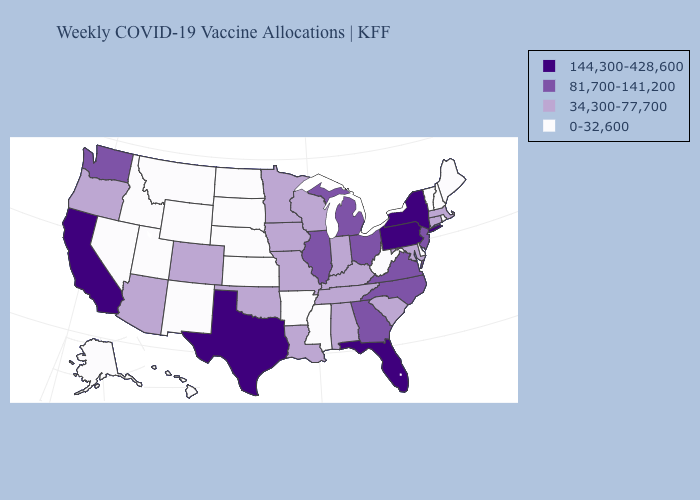What is the highest value in the USA?
Concise answer only. 144,300-428,600. What is the highest value in the USA?
Concise answer only. 144,300-428,600. Among the states that border Oklahoma , which have the highest value?
Be succinct. Texas. Name the states that have a value in the range 81,700-141,200?
Write a very short answer. Georgia, Illinois, Michigan, New Jersey, North Carolina, Ohio, Virginia, Washington. Name the states that have a value in the range 144,300-428,600?
Give a very brief answer. California, Florida, New York, Pennsylvania, Texas. Does California have the highest value in the West?
Write a very short answer. Yes. Does Alabama have a lower value than Florida?
Give a very brief answer. Yes. Name the states that have a value in the range 0-32,600?
Keep it brief. Alaska, Arkansas, Delaware, Hawaii, Idaho, Kansas, Maine, Mississippi, Montana, Nebraska, Nevada, New Hampshire, New Mexico, North Dakota, Rhode Island, South Dakota, Utah, Vermont, West Virginia, Wyoming. Name the states that have a value in the range 0-32,600?
Write a very short answer. Alaska, Arkansas, Delaware, Hawaii, Idaho, Kansas, Maine, Mississippi, Montana, Nebraska, Nevada, New Hampshire, New Mexico, North Dakota, Rhode Island, South Dakota, Utah, Vermont, West Virginia, Wyoming. Does Texas have the same value as California?
Write a very short answer. Yes. What is the value of Alabama?
Answer briefly. 34,300-77,700. What is the highest value in states that border Pennsylvania?
Be succinct. 144,300-428,600. What is the lowest value in the USA?
Short answer required. 0-32,600. Does Illinois have the same value as New Jersey?
Quick response, please. Yes. What is the value of Minnesota?
Write a very short answer. 34,300-77,700. 